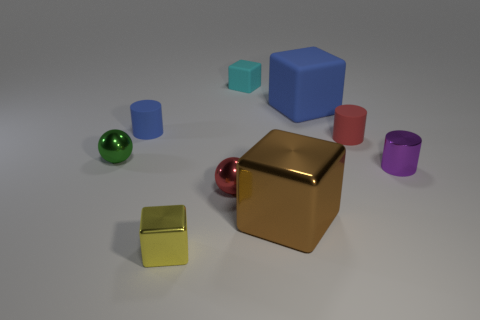Are there any big metallic blocks?
Provide a succinct answer. Yes. There is a large blue thing that is the same shape as the yellow thing; what is its material?
Your answer should be very brief. Rubber. Are there any blue rubber blocks behind the cyan thing?
Your response must be concise. No. Do the small sphere that is in front of the tiny green ball and the purple cylinder have the same material?
Your response must be concise. Yes. Are there any tiny metal balls of the same color as the large rubber object?
Offer a terse response. No. The big blue rubber object has what shape?
Your answer should be very brief. Cube. There is a metal ball behind the tiny red object that is in front of the small purple metal cylinder; what color is it?
Provide a succinct answer. Green. There is a rubber cylinder on the left side of the cyan cube; what is its size?
Offer a very short reply. Small. Are there any other brown objects that have the same material as the brown object?
Ensure brevity in your answer.  No. What number of brown objects have the same shape as the cyan matte thing?
Make the answer very short. 1. 